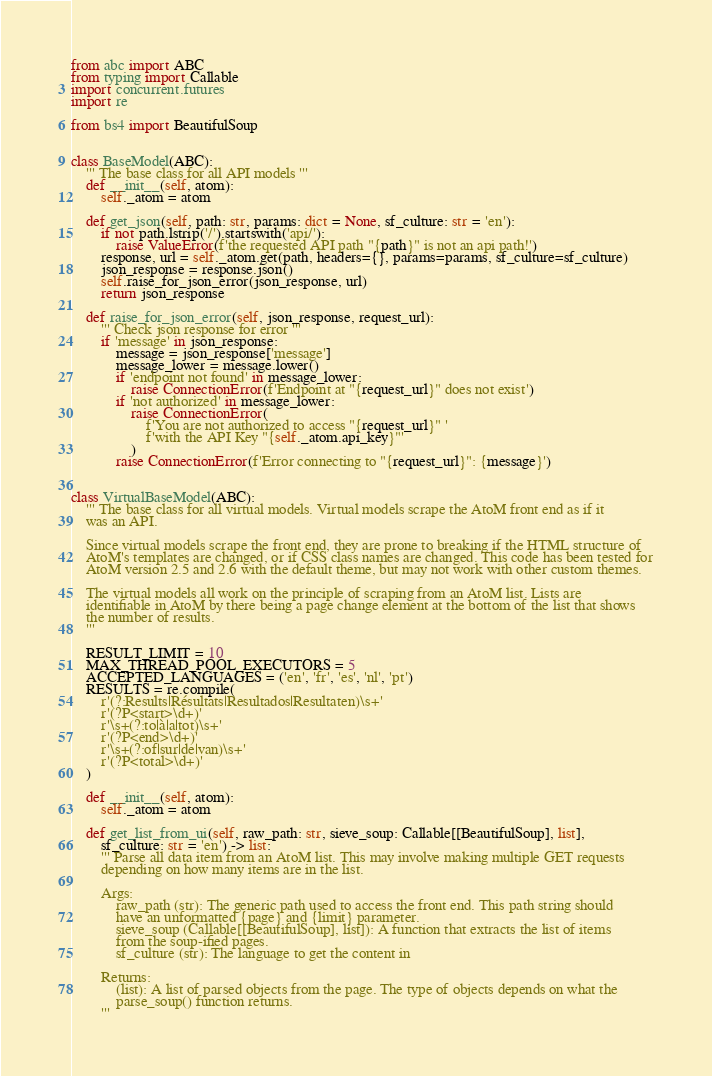<code> <loc_0><loc_0><loc_500><loc_500><_Python_>from abc import ABC
from typing import Callable
import concurrent.futures
import re

from bs4 import BeautifulSoup


class BaseModel(ABC):
    ''' The base class for all API models '''
    def __init__(self, atom):
        self._atom = atom

    def get_json(self, path: str, params: dict = None, sf_culture: str = 'en'):
        if not path.lstrip('/').startswith('api/'):
            raise ValueError(f'the requested API path "{path}" is not an api path!')
        response, url = self._atom.get(path, headers={}, params=params, sf_culture=sf_culture)
        json_response = response.json()
        self.raise_for_json_error(json_response, url)
        return json_response

    def raise_for_json_error(self, json_response, request_url):
        ''' Check json response for error '''
        if 'message' in json_response:
            message = json_response['message']
            message_lower = message.lower()
            if 'endpoint not found' in message_lower:
                raise ConnectionError(f'Endpoint at "{request_url}" does not exist')
            if 'not authorized' in message_lower:
                raise ConnectionError(
                    f'You are not authorized to access "{request_url}" '
                    f'with the API Key "{self._atom.api_key}"'
                )
            raise ConnectionError(f'Error connecting to "{request_url}": {message}')


class VirtualBaseModel(ABC):
    ''' The base class for all virtual models. Virtual models scrape the AtoM front end as if it
    was an API.

    Since virtual models scrape the front end, they are prone to breaking if the HTML structure of
    AtoM's templates are changed, or if CSS class names are changed. This code has been tested for
    AtoM version 2.5 and 2.6 with the default theme, but may not work with other custom themes.

    The virtual models all work on the principle of scraping from an AtoM list. Lists are
    identifiable in AtoM by there being a page change element at the bottom of the list that shows
    the number of results.
    '''

    RESULT_LIMIT = 10
    MAX_THREAD_POOL_EXECUTORS = 5
    ACCEPTED_LANGUAGES = ('en', 'fr', 'es', 'nl', 'pt')
    RESULTS = re.compile(
        r'(?:Results|Résultats|Resultados|Resultaten)\s+'
        r'(?P<start>\d+)'
        r'\s+(?:to|à|a|tot)\s+'
        r'(?P<end>\d+)'
        r'\s+(?:of|sur|de|van)\s+'
        r'(?P<total>\d+)'
    )

    def __init__(self, atom):
        self._atom = atom

    def get_list_from_ui(self, raw_path: str, sieve_soup: Callable[[BeautifulSoup], list],
        sf_culture: str = 'en') -> list:
        ''' Parse all data item from an AtoM list. This may involve making multiple GET requests
        depending on how many items are in the list.

        Args:
            raw_path (str): The generic path used to access the front end. This path string should
            have an unformatted {page} and {limit} parameter.
            sieve_soup (Callable[[BeautifulSoup], list]): A function that extracts the list of items
            from the soup-ified pages.
            sf_culture (str): The language to get the content in

        Returns:
            (list): A list of parsed objects from the page. The type of objects depends on what the
            parse_soup() function returns.
        '''</code> 